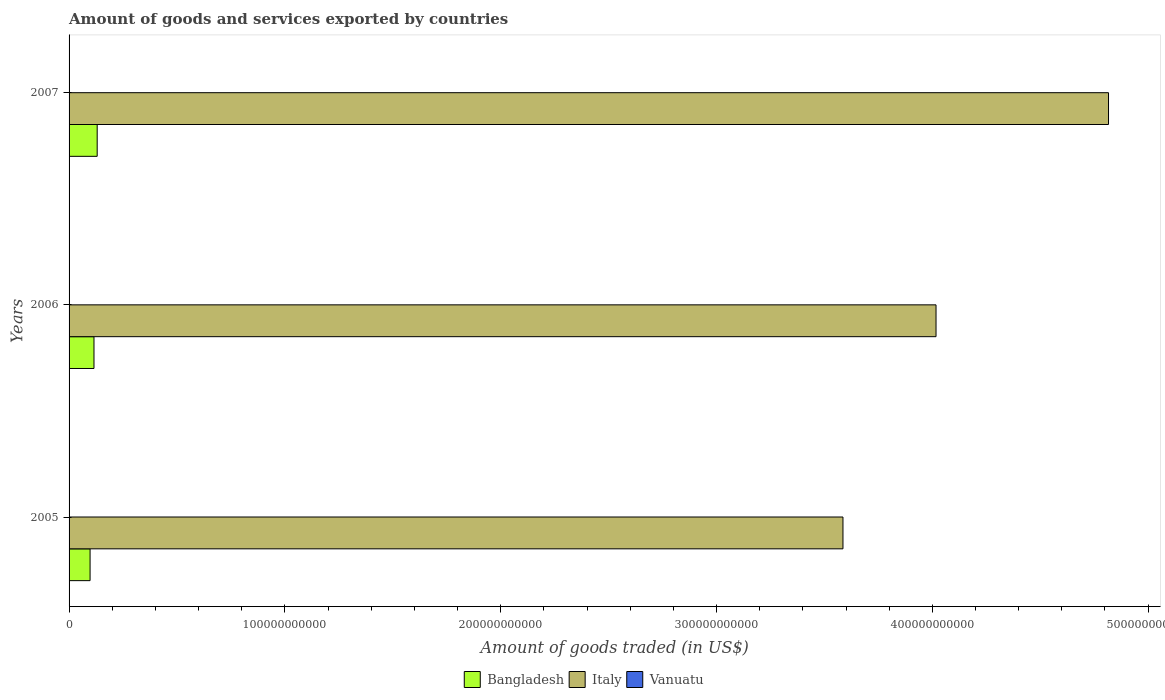How many different coloured bars are there?
Your answer should be very brief. 3. How many groups of bars are there?
Provide a succinct answer. 3. Are the number of bars on each tick of the Y-axis equal?
Ensure brevity in your answer.  Yes. How many bars are there on the 3rd tick from the top?
Keep it short and to the point. 3. What is the total amount of goods and services exported in Vanuatu in 2006?
Your answer should be compact. 3.77e+07. Across all years, what is the maximum total amount of goods and services exported in Bangladesh?
Your answer should be compact. 1.30e+1. Across all years, what is the minimum total amount of goods and services exported in Bangladesh?
Provide a succinct answer. 9.73e+09. In which year was the total amount of goods and services exported in Italy maximum?
Your answer should be very brief. 2007. In which year was the total amount of goods and services exported in Italy minimum?
Keep it short and to the point. 2005. What is the total total amount of goods and services exported in Bangladesh in the graph?
Offer a very short reply. 3.43e+1. What is the difference between the total amount of goods and services exported in Italy in 2005 and that in 2007?
Your response must be concise. -1.23e+11. What is the difference between the total amount of goods and services exported in Vanuatu in 2006 and the total amount of goods and services exported in Italy in 2005?
Provide a short and direct response. -3.59e+11. What is the average total amount of goods and services exported in Italy per year?
Give a very brief answer. 4.14e+11. In the year 2007, what is the difference between the total amount of goods and services exported in Bangladesh and total amount of goods and services exported in Vanuatu?
Keep it short and to the point. 1.30e+1. What is the ratio of the total amount of goods and services exported in Vanuatu in 2005 to that in 2006?
Keep it short and to the point. 1.01. Is the total amount of goods and services exported in Vanuatu in 2005 less than that in 2007?
Make the answer very short. No. Is the difference between the total amount of goods and services exported in Bangladesh in 2005 and 2007 greater than the difference between the total amount of goods and services exported in Vanuatu in 2005 and 2007?
Offer a terse response. No. What is the difference between the highest and the second highest total amount of goods and services exported in Italy?
Ensure brevity in your answer.  7.99e+1. What is the difference between the highest and the lowest total amount of goods and services exported in Bangladesh?
Ensure brevity in your answer.  3.30e+09. What does the 3rd bar from the bottom in 2007 represents?
Provide a succinct answer. Vanuatu. How many bars are there?
Offer a terse response. 9. Are all the bars in the graph horizontal?
Give a very brief answer. Yes. How many years are there in the graph?
Give a very brief answer. 3. What is the difference between two consecutive major ticks on the X-axis?
Your answer should be very brief. 1.00e+11. Are the values on the major ticks of X-axis written in scientific E-notation?
Offer a terse response. No. Does the graph contain grids?
Your answer should be very brief. No. What is the title of the graph?
Offer a very short reply. Amount of goods and services exported by countries. Does "Nepal" appear as one of the legend labels in the graph?
Keep it short and to the point. No. What is the label or title of the X-axis?
Provide a short and direct response. Amount of goods traded (in US$). What is the label or title of the Y-axis?
Your response must be concise. Years. What is the Amount of goods traded (in US$) of Bangladesh in 2005?
Keep it short and to the point. 9.73e+09. What is the Amount of goods traded (in US$) of Italy in 2005?
Offer a very short reply. 3.59e+11. What is the Amount of goods traded (in US$) of Vanuatu in 2005?
Keep it short and to the point. 3.81e+07. What is the Amount of goods traded (in US$) of Bangladesh in 2006?
Your answer should be very brief. 1.15e+1. What is the Amount of goods traded (in US$) in Italy in 2006?
Your answer should be compact. 4.02e+11. What is the Amount of goods traded (in US$) of Vanuatu in 2006?
Give a very brief answer. 3.77e+07. What is the Amount of goods traded (in US$) of Bangladesh in 2007?
Ensure brevity in your answer.  1.30e+1. What is the Amount of goods traded (in US$) of Italy in 2007?
Provide a succinct answer. 4.82e+11. What is the Amount of goods traded (in US$) of Vanuatu in 2007?
Provide a succinct answer. 3.35e+07. Across all years, what is the maximum Amount of goods traded (in US$) in Bangladesh?
Your answer should be very brief. 1.30e+1. Across all years, what is the maximum Amount of goods traded (in US$) in Italy?
Ensure brevity in your answer.  4.82e+11. Across all years, what is the maximum Amount of goods traded (in US$) in Vanuatu?
Ensure brevity in your answer.  3.81e+07. Across all years, what is the minimum Amount of goods traded (in US$) in Bangladesh?
Your answer should be compact. 9.73e+09. Across all years, what is the minimum Amount of goods traded (in US$) in Italy?
Ensure brevity in your answer.  3.59e+11. Across all years, what is the minimum Amount of goods traded (in US$) in Vanuatu?
Offer a very short reply. 3.35e+07. What is the total Amount of goods traded (in US$) of Bangladesh in the graph?
Offer a very short reply. 3.43e+1. What is the total Amount of goods traded (in US$) of Italy in the graph?
Ensure brevity in your answer.  1.24e+12. What is the total Amount of goods traded (in US$) in Vanuatu in the graph?
Your answer should be compact. 1.09e+08. What is the difference between the Amount of goods traded (in US$) in Bangladesh in 2005 and that in 2006?
Offer a very short reply. -1.81e+09. What is the difference between the Amount of goods traded (in US$) in Italy in 2005 and that in 2006?
Ensure brevity in your answer.  -4.31e+1. What is the difference between the Amount of goods traded (in US$) of Vanuatu in 2005 and that in 2006?
Ensure brevity in your answer.  4.18e+05. What is the difference between the Amount of goods traded (in US$) in Bangladesh in 2005 and that in 2007?
Make the answer very short. -3.30e+09. What is the difference between the Amount of goods traded (in US$) in Italy in 2005 and that in 2007?
Make the answer very short. -1.23e+11. What is the difference between the Amount of goods traded (in US$) in Vanuatu in 2005 and that in 2007?
Provide a short and direct response. 4.57e+06. What is the difference between the Amount of goods traded (in US$) in Bangladesh in 2006 and that in 2007?
Make the answer very short. -1.48e+09. What is the difference between the Amount of goods traded (in US$) of Italy in 2006 and that in 2007?
Provide a succinct answer. -7.99e+1. What is the difference between the Amount of goods traded (in US$) in Vanuatu in 2006 and that in 2007?
Offer a very short reply. 4.15e+06. What is the difference between the Amount of goods traded (in US$) in Bangladesh in 2005 and the Amount of goods traded (in US$) in Italy in 2006?
Offer a very short reply. -3.92e+11. What is the difference between the Amount of goods traded (in US$) in Bangladesh in 2005 and the Amount of goods traded (in US$) in Vanuatu in 2006?
Give a very brief answer. 9.69e+09. What is the difference between the Amount of goods traded (in US$) of Italy in 2005 and the Amount of goods traded (in US$) of Vanuatu in 2006?
Offer a terse response. 3.59e+11. What is the difference between the Amount of goods traded (in US$) in Bangladesh in 2005 and the Amount of goods traded (in US$) in Italy in 2007?
Your answer should be compact. -4.72e+11. What is the difference between the Amount of goods traded (in US$) in Bangladesh in 2005 and the Amount of goods traded (in US$) in Vanuatu in 2007?
Offer a very short reply. 9.70e+09. What is the difference between the Amount of goods traded (in US$) in Italy in 2005 and the Amount of goods traded (in US$) in Vanuatu in 2007?
Your response must be concise. 3.59e+11. What is the difference between the Amount of goods traded (in US$) in Bangladesh in 2006 and the Amount of goods traded (in US$) in Italy in 2007?
Provide a short and direct response. -4.70e+11. What is the difference between the Amount of goods traded (in US$) of Bangladesh in 2006 and the Amount of goods traded (in US$) of Vanuatu in 2007?
Give a very brief answer. 1.15e+1. What is the difference between the Amount of goods traded (in US$) of Italy in 2006 and the Amount of goods traded (in US$) of Vanuatu in 2007?
Provide a succinct answer. 4.02e+11. What is the average Amount of goods traded (in US$) in Bangladesh per year?
Keep it short and to the point. 1.14e+1. What is the average Amount of goods traded (in US$) in Italy per year?
Make the answer very short. 4.14e+11. What is the average Amount of goods traded (in US$) of Vanuatu per year?
Provide a succinct answer. 3.65e+07. In the year 2005, what is the difference between the Amount of goods traded (in US$) of Bangladesh and Amount of goods traded (in US$) of Italy?
Offer a very short reply. -3.49e+11. In the year 2005, what is the difference between the Amount of goods traded (in US$) of Bangladesh and Amount of goods traded (in US$) of Vanuatu?
Provide a succinct answer. 9.69e+09. In the year 2005, what is the difference between the Amount of goods traded (in US$) of Italy and Amount of goods traded (in US$) of Vanuatu?
Keep it short and to the point. 3.59e+11. In the year 2006, what is the difference between the Amount of goods traded (in US$) of Bangladesh and Amount of goods traded (in US$) of Italy?
Ensure brevity in your answer.  -3.90e+11. In the year 2006, what is the difference between the Amount of goods traded (in US$) of Bangladesh and Amount of goods traded (in US$) of Vanuatu?
Your answer should be compact. 1.15e+1. In the year 2006, what is the difference between the Amount of goods traded (in US$) in Italy and Amount of goods traded (in US$) in Vanuatu?
Provide a succinct answer. 4.02e+11. In the year 2007, what is the difference between the Amount of goods traded (in US$) in Bangladesh and Amount of goods traded (in US$) in Italy?
Keep it short and to the point. -4.69e+11. In the year 2007, what is the difference between the Amount of goods traded (in US$) in Bangladesh and Amount of goods traded (in US$) in Vanuatu?
Ensure brevity in your answer.  1.30e+1. In the year 2007, what is the difference between the Amount of goods traded (in US$) in Italy and Amount of goods traded (in US$) in Vanuatu?
Provide a short and direct response. 4.82e+11. What is the ratio of the Amount of goods traded (in US$) of Bangladesh in 2005 to that in 2006?
Your answer should be very brief. 0.84. What is the ratio of the Amount of goods traded (in US$) in Italy in 2005 to that in 2006?
Offer a very short reply. 0.89. What is the ratio of the Amount of goods traded (in US$) in Vanuatu in 2005 to that in 2006?
Provide a short and direct response. 1.01. What is the ratio of the Amount of goods traded (in US$) of Bangladesh in 2005 to that in 2007?
Keep it short and to the point. 0.75. What is the ratio of the Amount of goods traded (in US$) in Italy in 2005 to that in 2007?
Offer a very short reply. 0.74. What is the ratio of the Amount of goods traded (in US$) of Vanuatu in 2005 to that in 2007?
Provide a short and direct response. 1.14. What is the ratio of the Amount of goods traded (in US$) in Bangladesh in 2006 to that in 2007?
Your answer should be compact. 0.89. What is the ratio of the Amount of goods traded (in US$) in Italy in 2006 to that in 2007?
Ensure brevity in your answer.  0.83. What is the ratio of the Amount of goods traded (in US$) of Vanuatu in 2006 to that in 2007?
Provide a succinct answer. 1.12. What is the difference between the highest and the second highest Amount of goods traded (in US$) of Bangladesh?
Provide a succinct answer. 1.48e+09. What is the difference between the highest and the second highest Amount of goods traded (in US$) in Italy?
Offer a very short reply. 7.99e+1. What is the difference between the highest and the second highest Amount of goods traded (in US$) of Vanuatu?
Your answer should be compact. 4.18e+05. What is the difference between the highest and the lowest Amount of goods traded (in US$) of Bangladesh?
Provide a succinct answer. 3.30e+09. What is the difference between the highest and the lowest Amount of goods traded (in US$) of Italy?
Keep it short and to the point. 1.23e+11. What is the difference between the highest and the lowest Amount of goods traded (in US$) of Vanuatu?
Provide a succinct answer. 4.57e+06. 